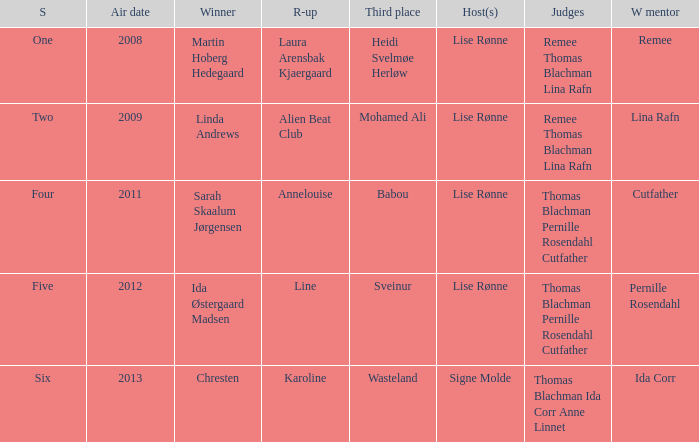Give me the full table as a dictionary. {'header': ['S', 'Air date', 'Winner', 'R-up', 'Third place', 'Host(s)', 'Judges', 'W mentor'], 'rows': [['One', '2008', 'Martin Hoberg Hedegaard', 'Laura Arensbak Kjaergaard', 'Heidi Svelmøe Herløw', 'Lise Rønne', 'Remee Thomas Blachman Lina Rafn', 'Remee'], ['Two', '2009', 'Linda Andrews', 'Alien Beat Club', 'Mohamed Ali', 'Lise Rønne', 'Remee Thomas Blachman Lina Rafn', 'Lina Rafn'], ['Four', '2011', 'Sarah Skaalum Jørgensen', 'Annelouise', 'Babou', 'Lise Rønne', 'Thomas Blachman Pernille Rosendahl Cutfather', 'Cutfather'], ['Five', '2012', 'Ida Østergaard Madsen', 'Line', 'Sveinur', 'Lise Rønne', 'Thomas Blachman Pernille Rosendahl Cutfather', 'Pernille Rosendahl'], ['Six', '2013', 'Chresten', 'Karoline', 'Wasteland', 'Signe Molde', 'Thomas Blachman Ida Corr Anne Linnet', 'Ida Corr']]} Who was the winning mentor in season two? Lina Rafn. 